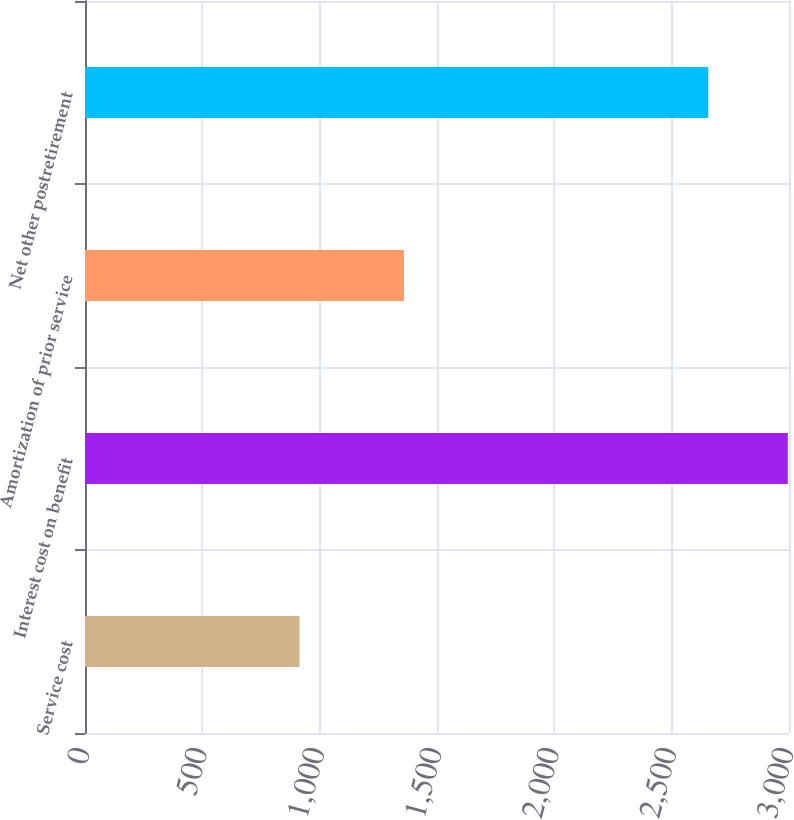Convert chart to OTSL. <chart><loc_0><loc_0><loc_500><loc_500><bar_chart><fcel>Service cost<fcel>Interest cost on benefit<fcel>Amortization of prior service<fcel>Net other postretirement<nl><fcel>914<fcel>2995<fcel>1359<fcel>2656<nl></chart> 